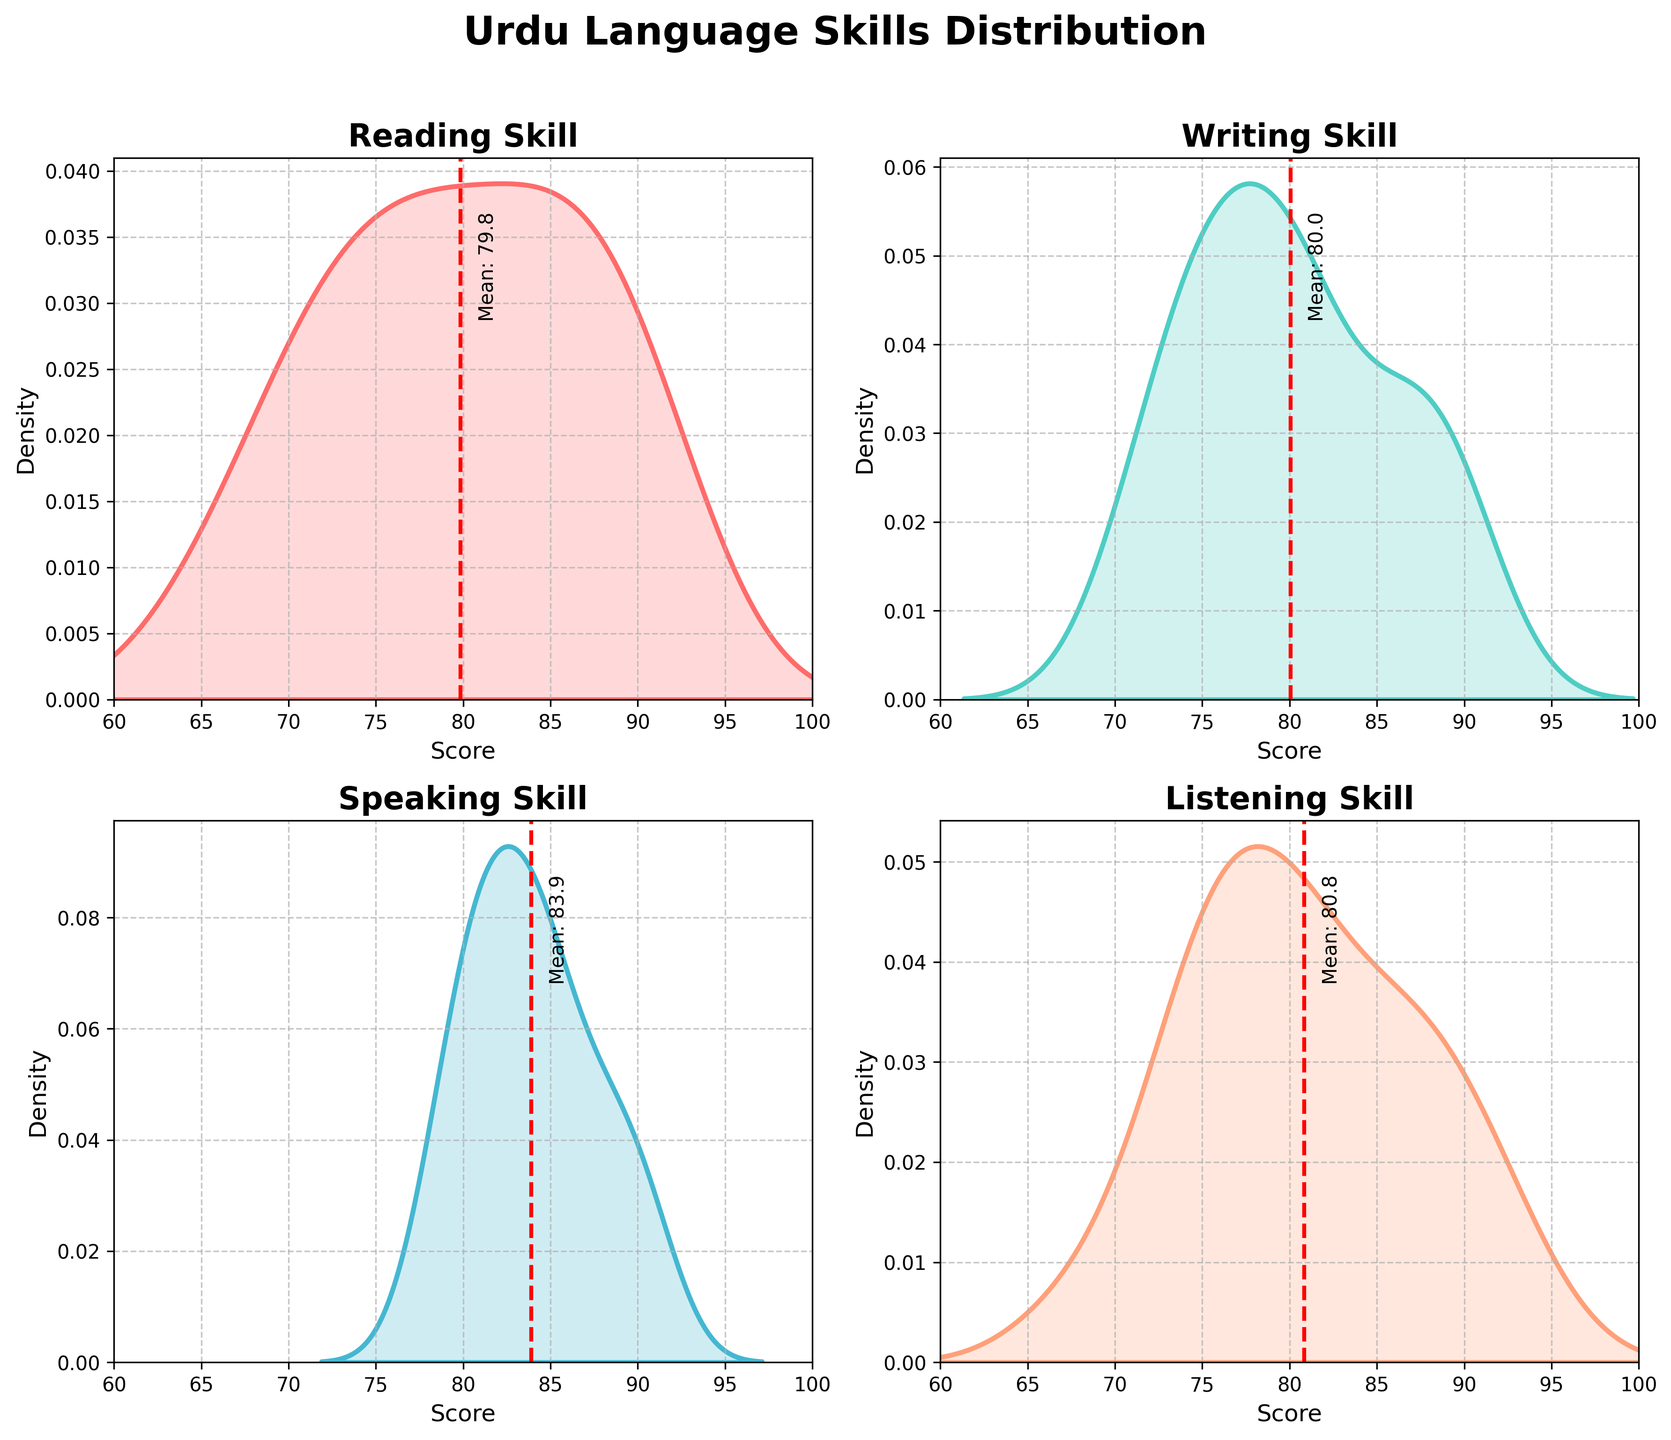What is the title of the figure? The title of the figure is written at the top of the combined plots, it summarizes the main subject of the data visualization. The title in this case is 'Urdu Language Skills Distribution'.
Answer: Urdu Language Skills Distribution Which skill has the highest peak density among the four plots? To determine which skill has the highest peak density, examine the density curves and identify the one that is tallest. Each plot has a skill density curve with an area filled in.
Answer: Reading What is the mean score for the Writing skill? The mean score is indicated by a vertical dashed red line with a label 'Mean' on each subplot. Look at the Writing subplot and find the value where the red line intersects the x-axis.
Answer: 80.1 Among the four skills, which two have the closest mean scores? To find this, compare the mean values indicated by the red dashed lines across the four subplots. Identify the two skills with the mean values that are numerically closest to each other.
Answer: Speaking and Listening What is the score range displayed on the x-axis for all subplots? The x-axis range is shown beneath each density plot. It indicates the range of scores used to plot the density curves for each Urdu language skill.
Answer: 60 to 100 How does the mean score for the Reading skill compare to the means of the other skills? Observe the mean scores from the Reading skill and compare these with the mean scores of Writing, Speaking, and Listening by looking at the red dashed lines and their values on the x-axis.
Answer: Higher than Writing, lower than Listening Which skill shows the lowest density peak? Check each density plot to find the peak (the highest point) of the curve, then identify the one that is the lowest among Reading, Writing, Speaking, and Listening.
Answer: Listening Do Reading and Writing skills have similar score distributions? Examine the shape and spread of the density curves for Reading and Writing. If they have similar heights, shapes, and spreads, their distributions are similar.
Answer: Yes What does the area under each density curve represent? The area under each density curve represents the probability distribution of the students' scores in that specific Urdu skill. The total area under each density curve equals 1, showing the relative frequency of scores.
Answer: Probability distribution 